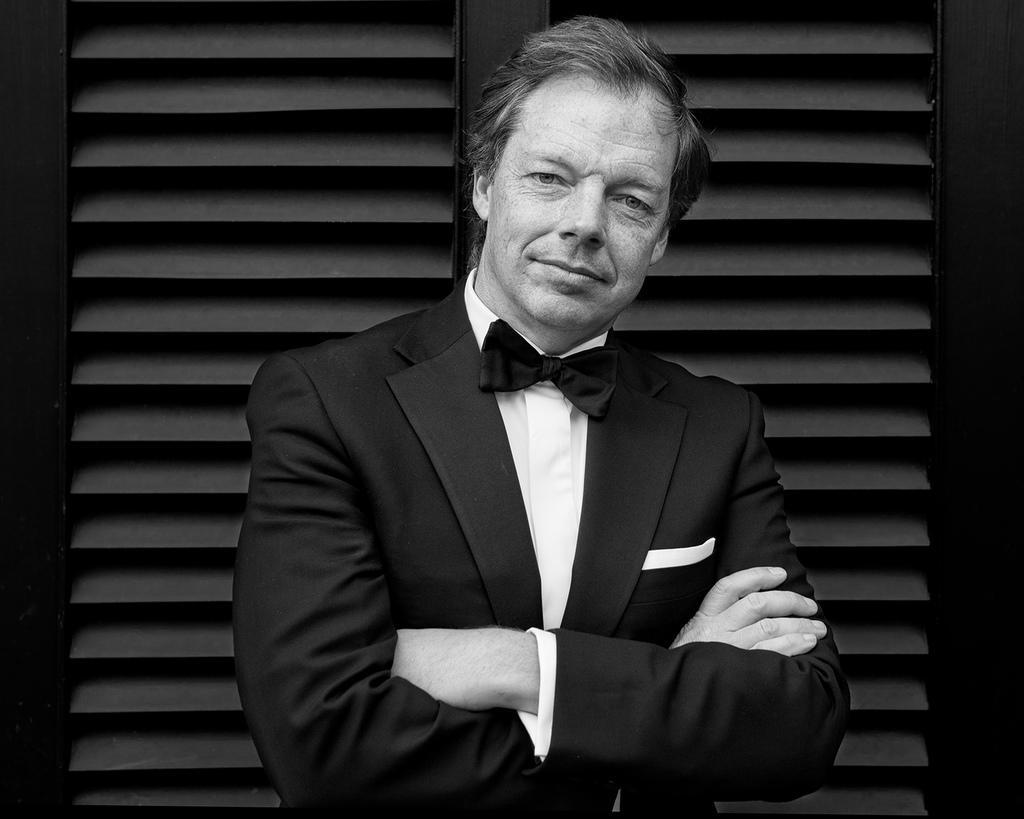Describe this image in one or two sentences. This is a black and white pic. Here we can see a man is standing and folding his hands and behind him there is a door. 